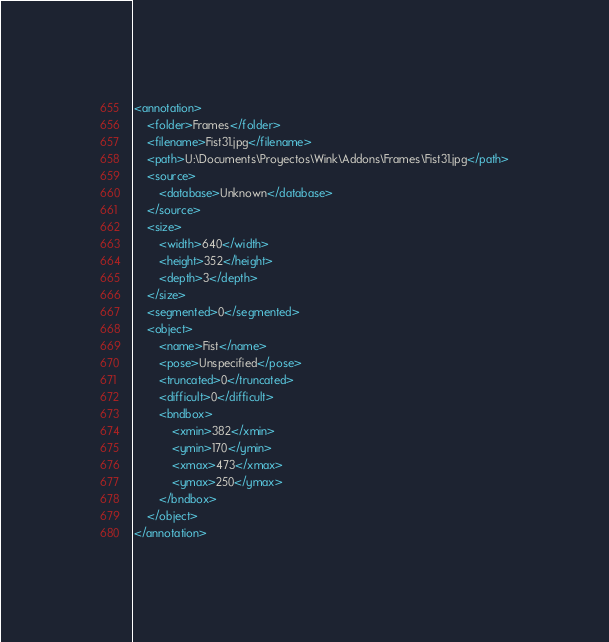<code> <loc_0><loc_0><loc_500><loc_500><_XML_><annotation>
	<folder>Frames</folder>
	<filename>Fist31.jpg</filename>
	<path>U:\Documents\Proyectos\Wink\Addons\Frames\Fist31.jpg</path>
	<source>
		<database>Unknown</database>
	</source>
	<size>
		<width>640</width>
		<height>352</height>
		<depth>3</depth>
	</size>
	<segmented>0</segmented>
	<object>
		<name>Fist</name>
		<pose>Unspecified</pose>
		<truncated>0</truncated>
		<difficult>0</difficult>
		<bndbox>
			<xmin>382</xmin>
			<ymin>170</ymin>
			<xmax>473</xmax>
			<ymax>250</ymax>
		</bndbox>
	</object>
</annotation>
</code> 